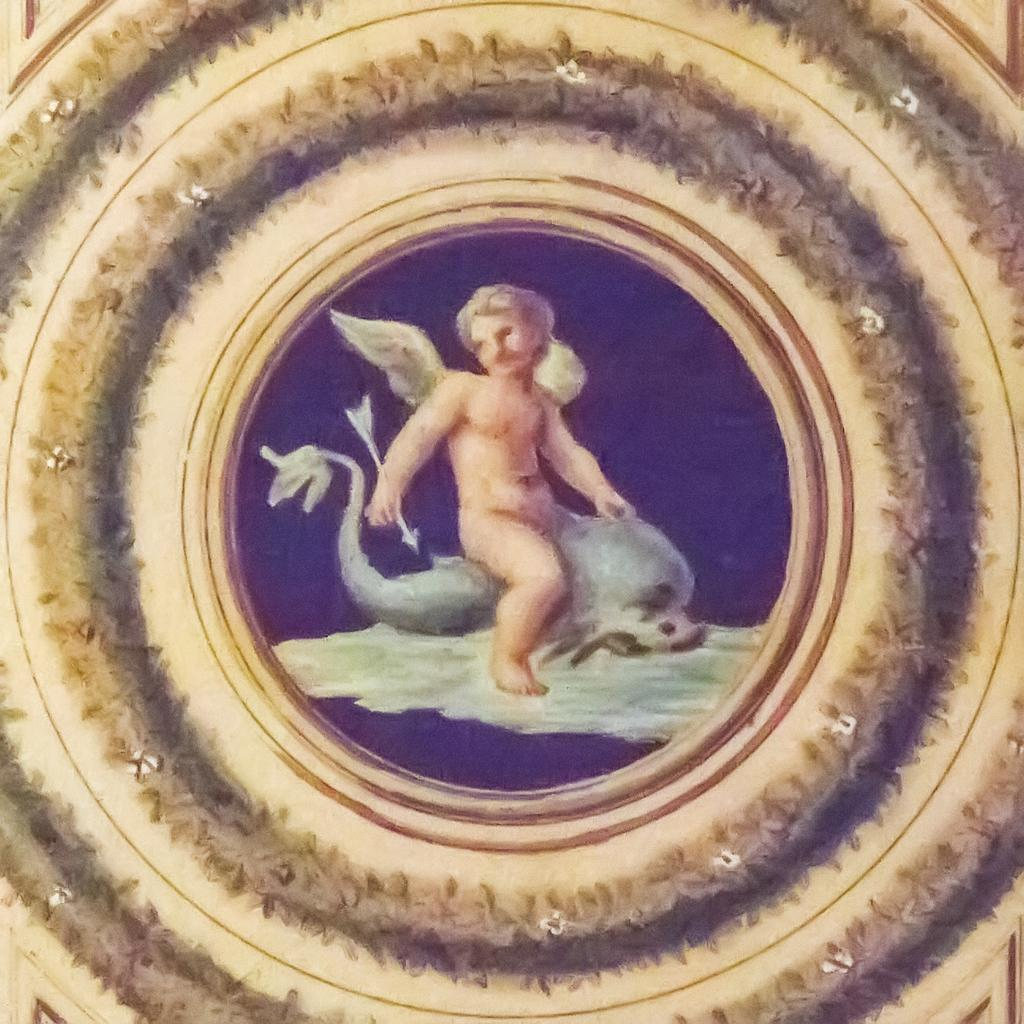What type of image is being depicted? The image is a mythological painting. Can you describe the main figure in the painting? There is a man with two wings in the image. What is the man holding in his hand? The man is holding an arrow in his hand. What is the man sitting on in the painting? The man is sitting on a dead whale. What type of fog can be seen surrounding the man in the image? There is no fog present in the image; it is a clear scene. How many screws are visible in the image? There are no screws present in the image. 